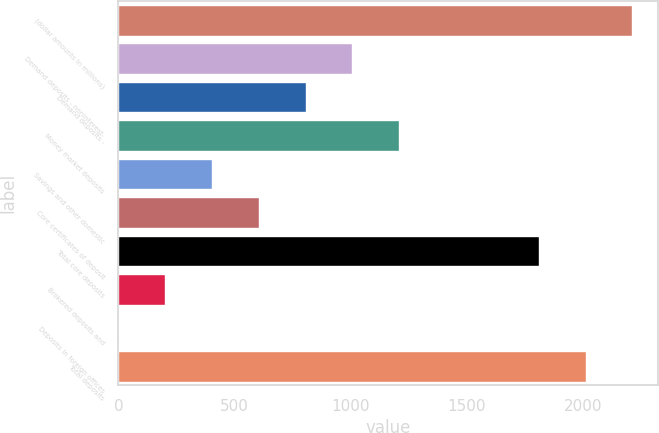Convert chart to OTSL. <chart><loc_0><loc_0><loc_500><loc_500><bar_chart><fcel>(dollar amounts in millions)<fcel>Demand deposits - noninterest-<fcel>Demand deposits -<fcel>Money market deposits<fcel>Savings and other domestic<fcel>Core certificates of deposit<fcel>Total core deposits<fcel>Brokered deposits and<fcel>Deposits in foreign offices<fcel>Total deposits<nl><fcel>2213.1<fcel>1006.5<fcel>805.4<fcel>1207.6<fcel>403.2<fcel>604.3<fcel>1810.9<fcel>202.1<fcel>1<fcel>2012<nl></chart> 